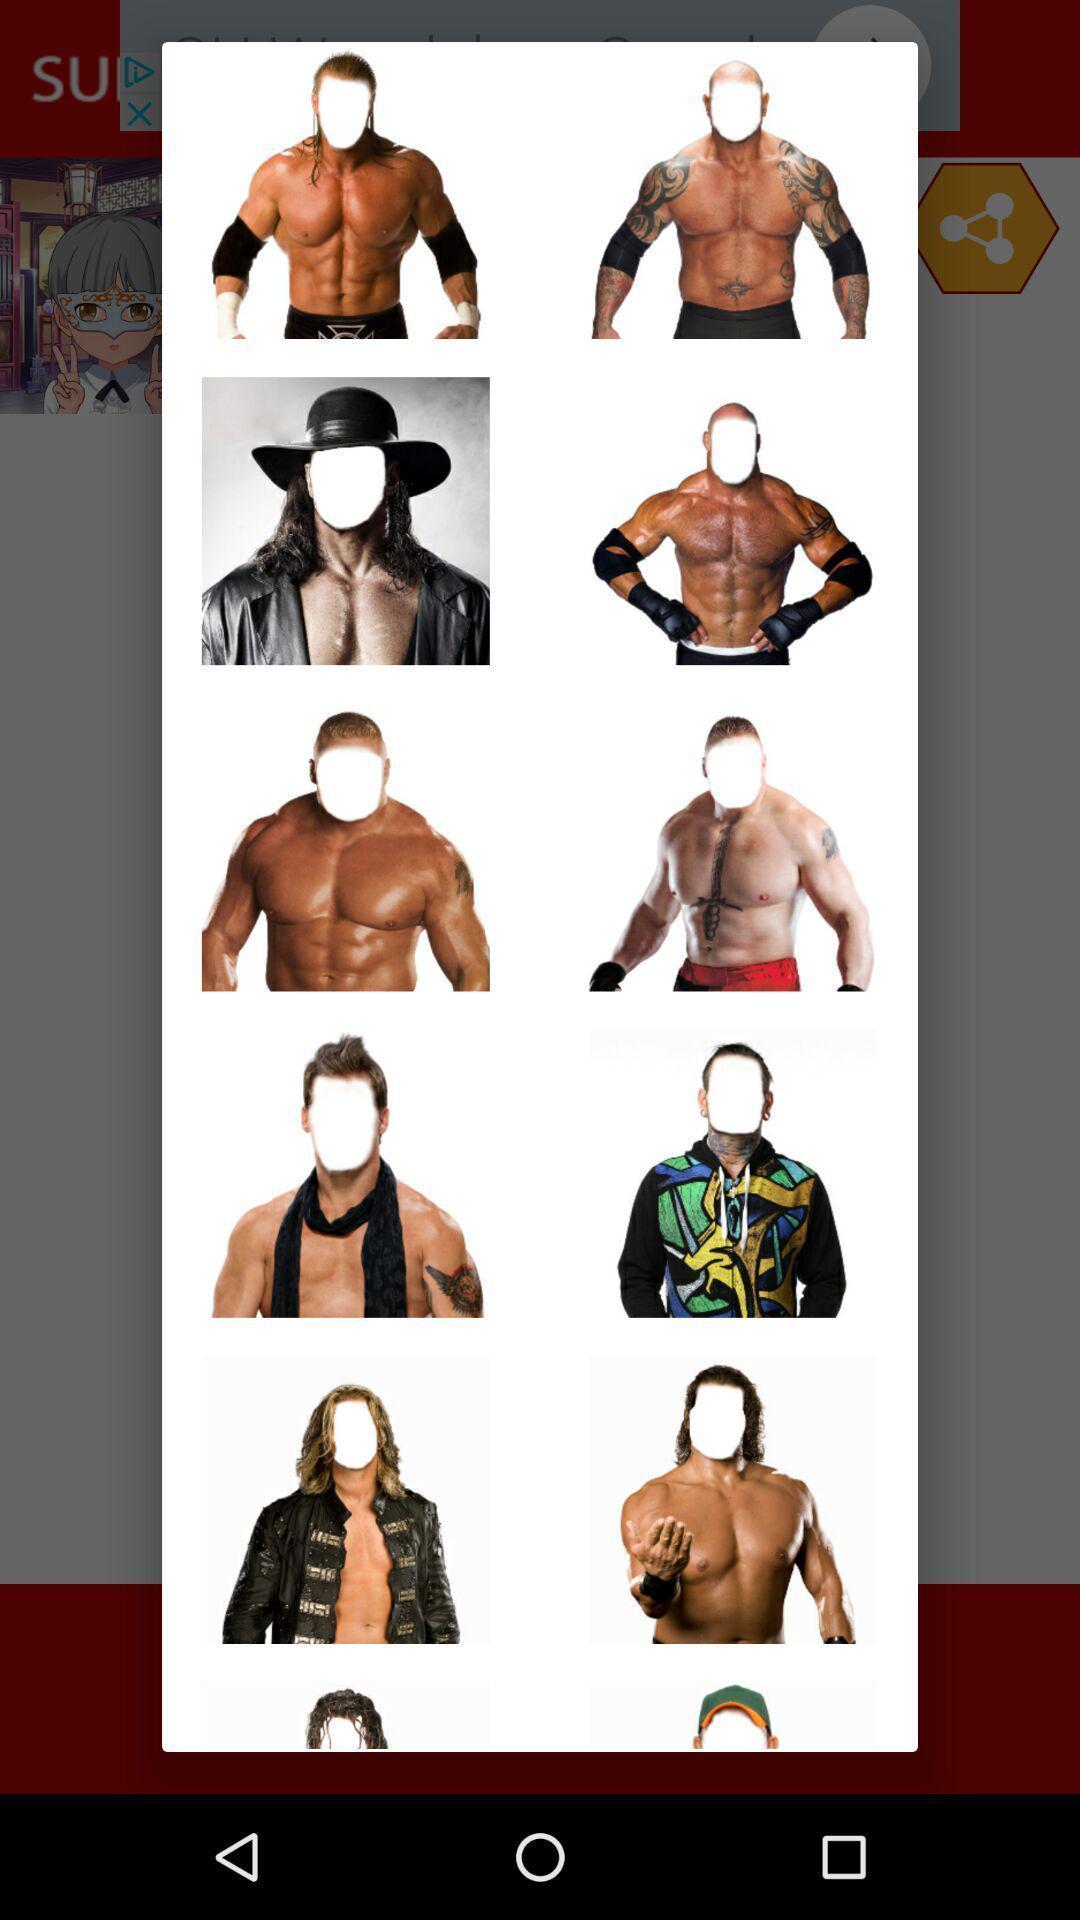Summarize the information in this screenshot. Pop up showing various face editing images. 